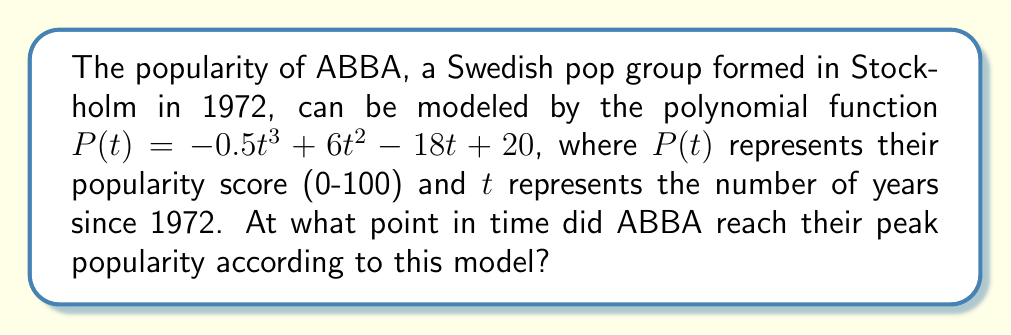Give your solution to this math problem. To find the peak popularity, we need to determine the maximum point of the polynomial function. This occurs where the derivative of the function equals zero.

Step 1: Find the derivative of $P(t)$
$$P'(t) = -1.5t^2 + 12t - 18$$

Step 2: Set the derivative equal to zero and solve for $t$
$$-1.5t^2 + 12t - 18 = 0$$

Step 3: Use the quadratic formula to solve this equation
$$t = \frac{-b \pm \sqrt{b^2 - 4ac}}{2a}$$
where $a = -1.5$, $b = 12$, and $c = -18$

$$t = \frac{-12 \pm \sqrt{12^2 - 4(-1.5)(-18)}}{2(-1.5)}$$
$$t = \frac{-12 \pm \sqrt{144 - 108}}{-3}$$
$$t = \frac{-12 \pm 6}{-3}$$

This gives us two solutions:
$$t = \frac{-12 + 6}{-3} = 2$$ or $$t = \frac{-12 - 6}{-3} = 6$$

Step 4: The second derivative of $P(t)$ is $P''(t) = -3t + 12$. At $t = 2$, $P''(2) = 6 > 0$, indicating a local minimum. At $t = 6$, $P''(6) = -6 < 0$, indicating a local maximum.

Therefore, ABBA reached their peak popularity 6 years after 1972, which is in 1978.
Answer: 1978 